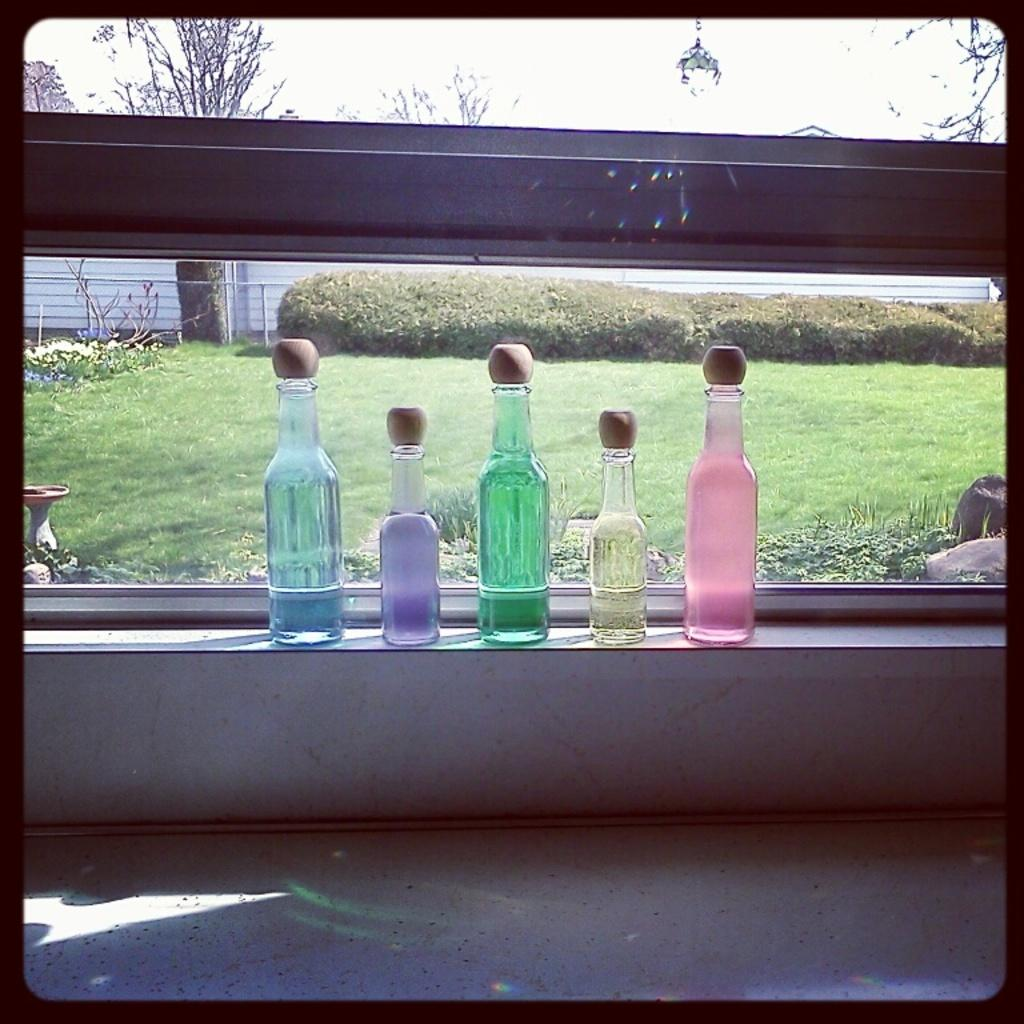What objects are in the image that come in different colors? There are bottles of different colors in the image. Where are the bottles located? The bottles are placed on a wall. What can be seen through the glass of the bottles? Grass, trees, and rods can be seen through the glass of the bottles. What stage of development can be observed in the image? There is no developmental stage present in the image, as it features bottles on a wall with a view through the glass. 